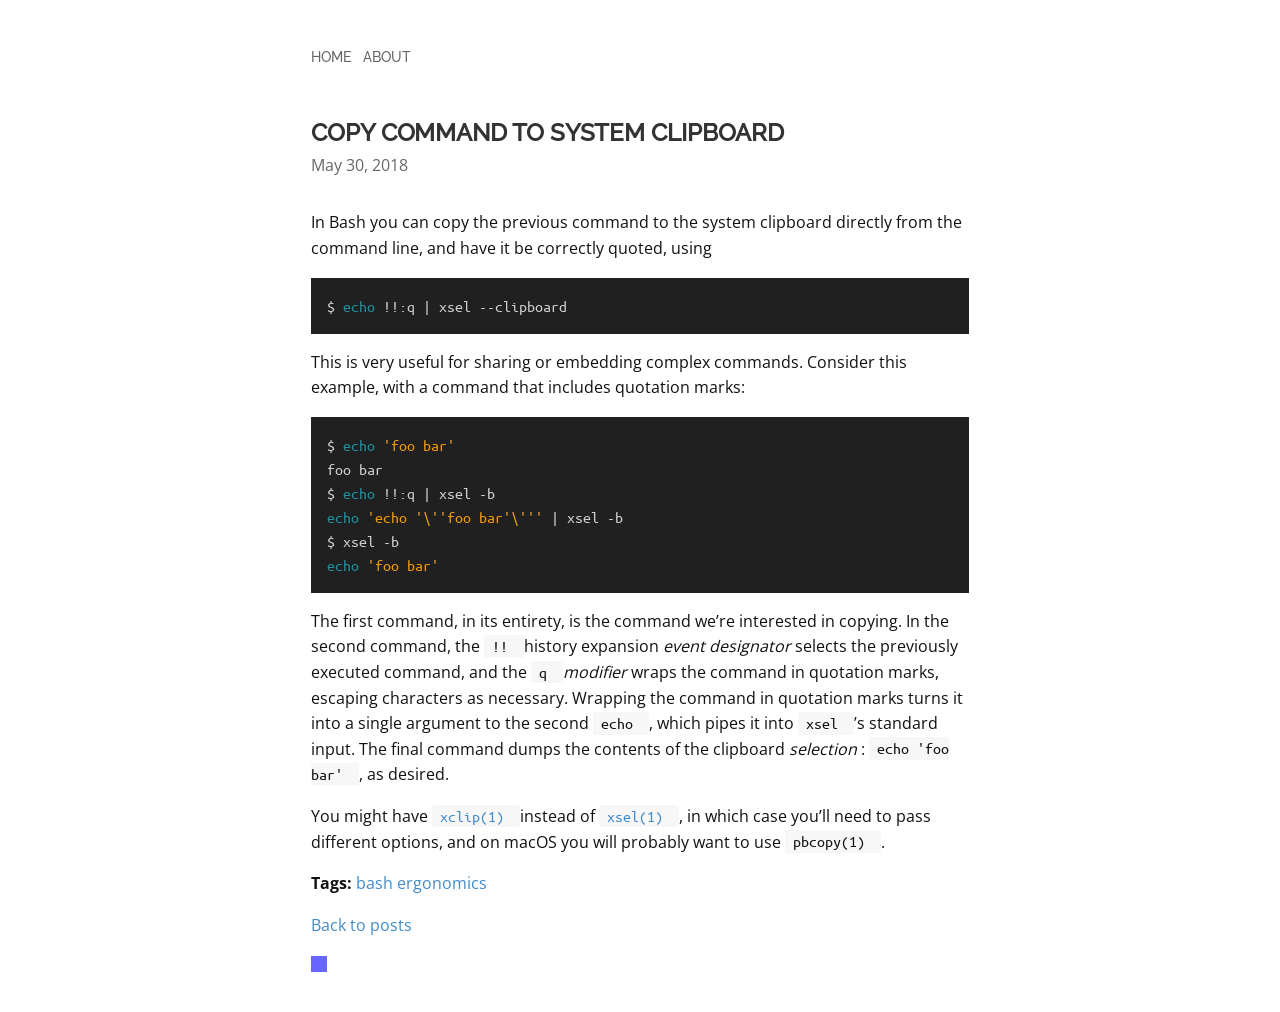Can you detail the steps to style the section visible in the image to look like a command terminal using CSS? To style a section so it appears like a command terminal, start by defining a <div> with a class 'terminal'. Use CSS to apply a dark background color, such as #333, and light-colored text, typically white or light gray. Utilize 'monospace' as the font family for an authentic look. Set padding within the div to separate the text from the edges, and manage spacing with 'line-height' to ensure it's easy to read. Optionally, create a box-shadow to give the terminal an inset effect, enhancing its realistic appearance.  What about making the website responsive to different devices? Making the website responsive involves using CSS media queries to adjust styles based on the device's screen size. Start by setting your CSS with mobile styles first, and use media queries to add styles for larger screens. Use percentages for width and 'max-width' properties to make elements scale proportionally. Employ 'flexbox' or 'grid' for layout to automatically adjust the positioning of elements based on screen size. Test on various devices to ensure compatibility and user-friendliness across all platforms. 